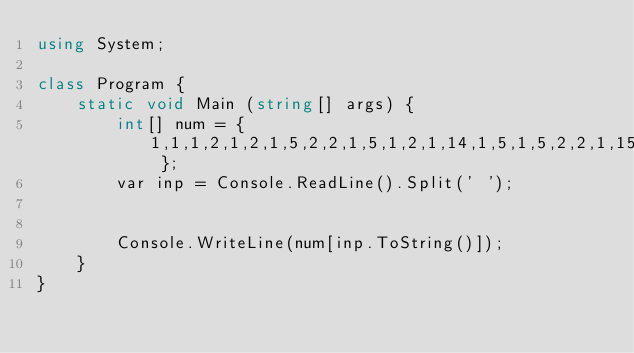<code> <loc_0><loc_0><loc_500><loc_500><_C#_>using System;

class Program {
    static void Main (string[] args) {
        int[] num = { 1,1,1,2,1,2,1,5,2,2,1,5,1,2,1,14,1,5,1,5,2,2,1,15,2,2,5,4,1,4,1,51 };
        var inp = Console.ReadLine().Split(' ');


        Console.WriteLine(num[inp.ToString()]);
    }
}</code> 